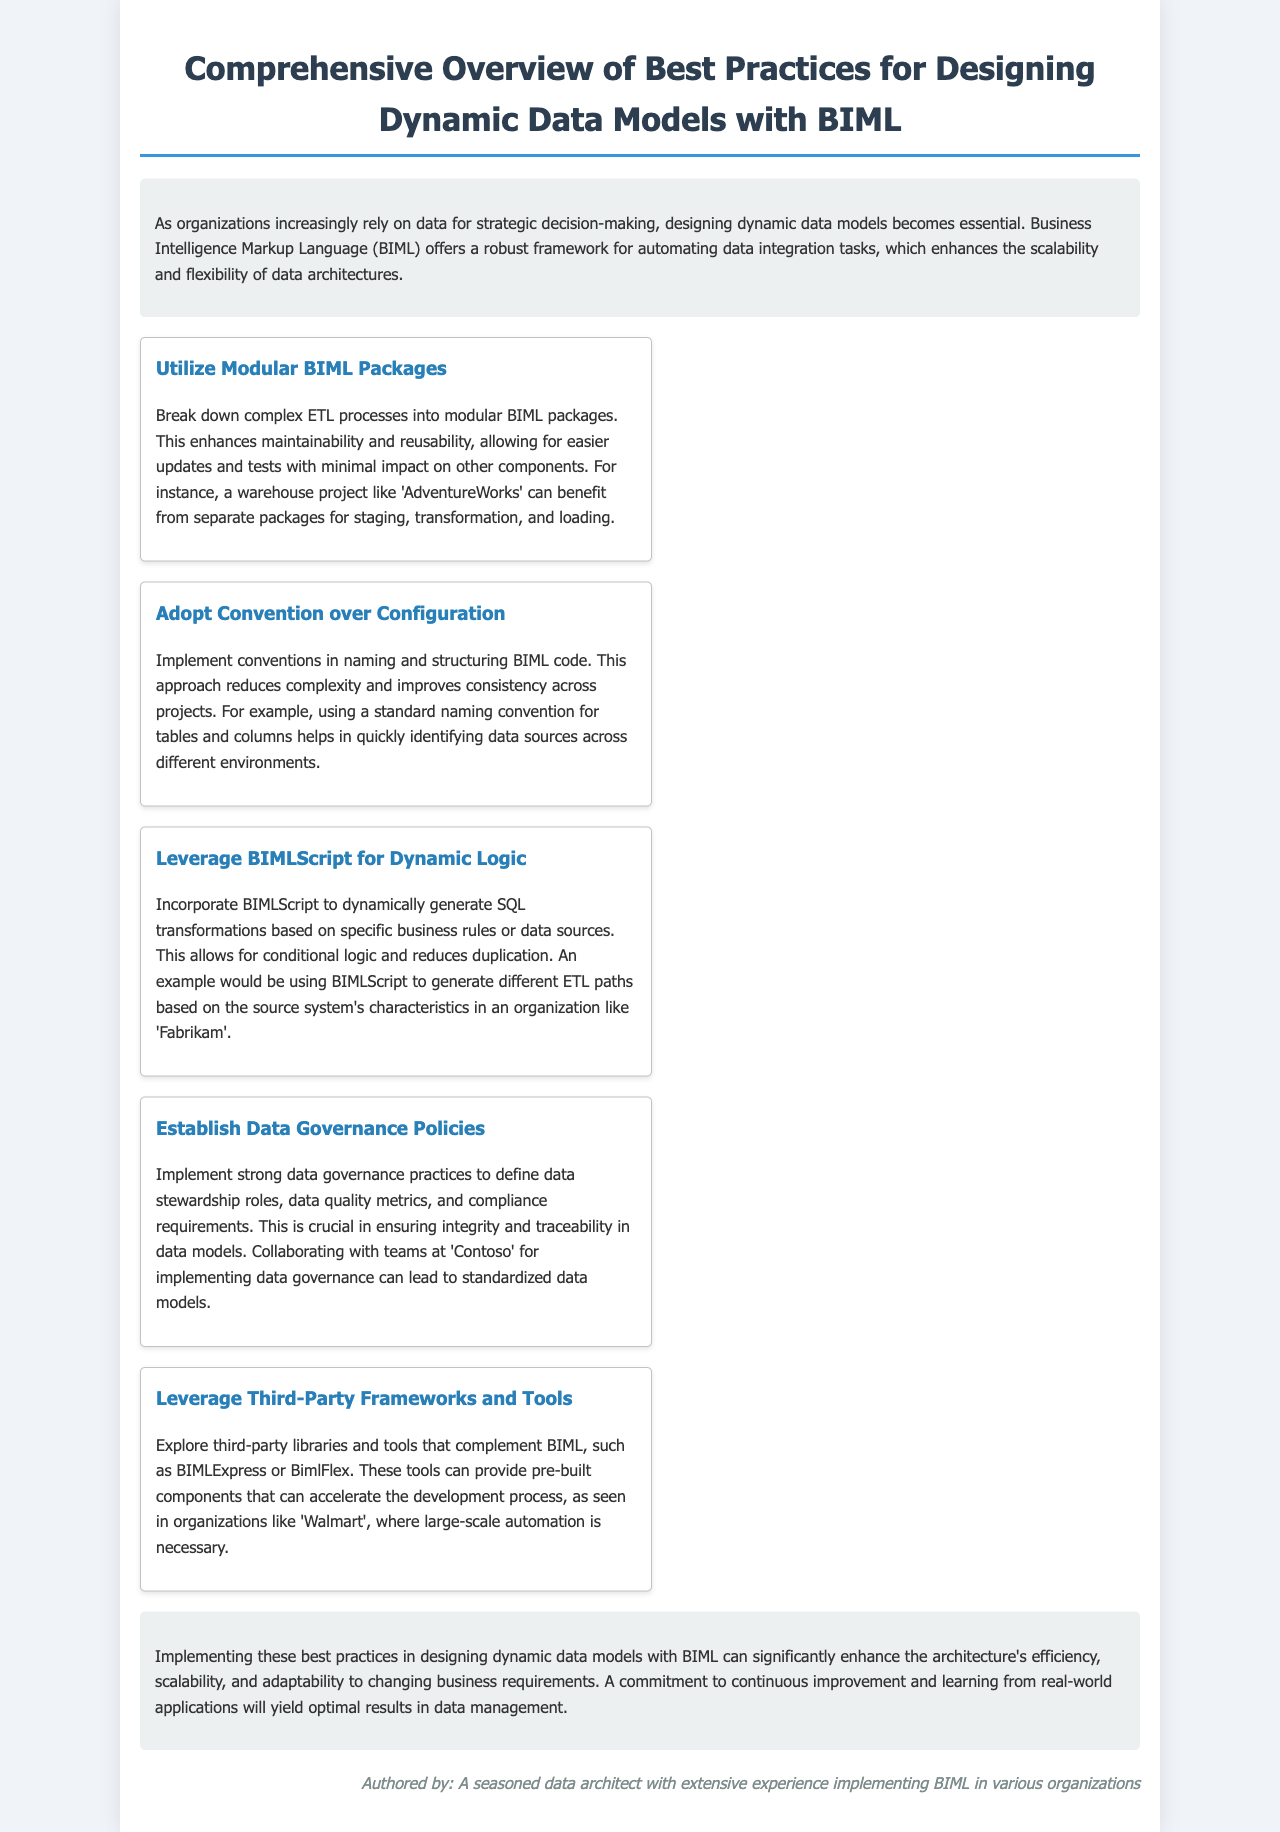What is the title of the document? The title is specified at the top of the document and encapsulates the main focus, which is on best practices for designing data models with BIML.
Answer: Comprehensive Overview of Best Practices for Designing Dynamic Data Models with BIML Who is the author of the document? The author is identified at the end of the document, providing credibility to the content.
Answer: A seasoned data architect with extensive experience implementing BIML in various organizations What are dynamic data models essential for? The introduction outlines the purpose of dynamic data models within organizational contexts, particularly regarding data utilization.
Answer: Strategic decision-making Name one best practice mentioned in the document. The document lists several best practices in sections, providing specific recommendations for BIML implementation.
Answer: Utilize Modular BIML Packages Which organization is mentioned in relation to implementing data governance? The document provides context of organizations relevant to the best practices and their contributions or applications.
Answer: Contoso What is the purpose of leveraging third-party frameworks? The document explains the rationale behind utilizing additional resources alongside BIML, highlighting the benefits they can bring to projects.
Answer: To accelerate the development process What is the main focus of the conclusion section? The conclusion summarizes the document’s key points regarding the effects of implementing the discussed practices on data architecture.
Answer: Efficiency, scalability, and adaptability How many best practices are included in the document? By counting the individual best practices outlined in the best practices section, we can determine the total number presented.
Answer: Five 